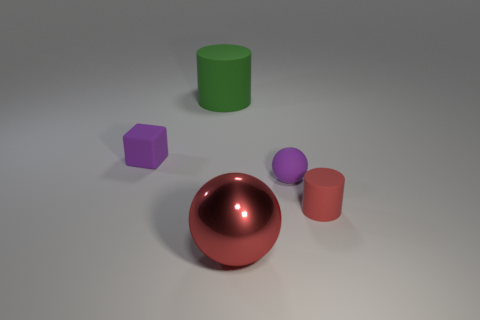Add 2 big green shiny balls. How many objects exist? 7 Subtract all cylinders. How many objects are left? 3 Add 1 matte things. How many matte things exist? 5 Subtract 1 red cylinders. How many objects are left? 4 Subtract all red cubes. Subtract all large matte objects. How many objects are left? 4 Add 4 green matte cylinders. How many green matte cylinders are left? 5 